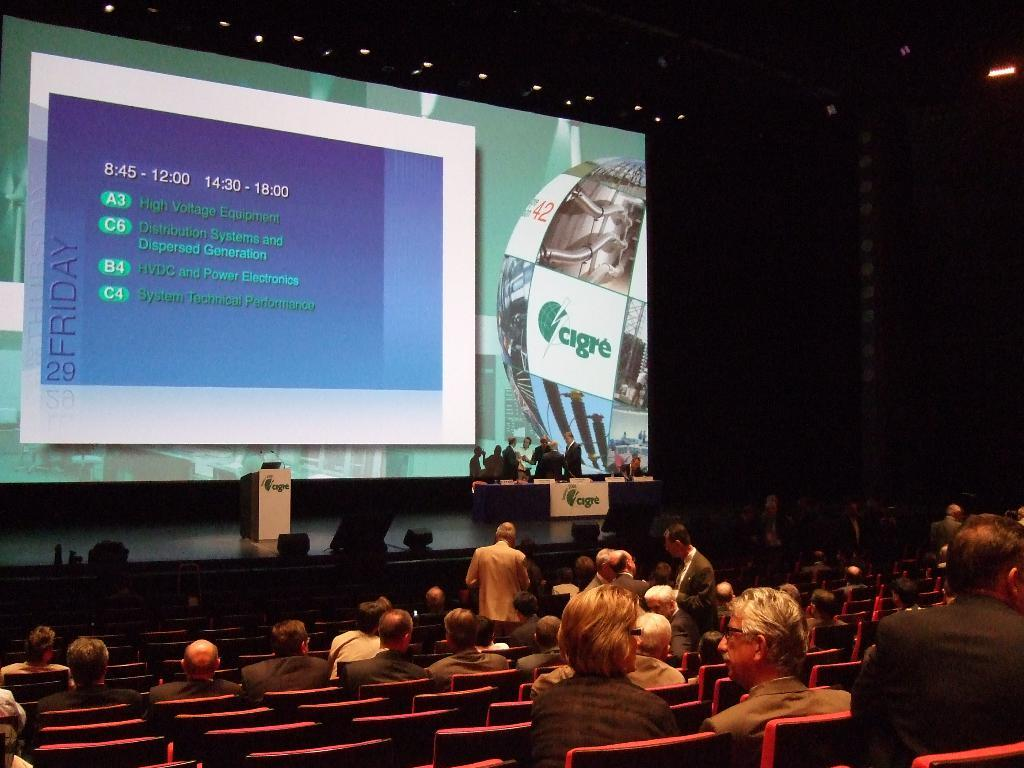<image>
Present a compact description of the photo's key features. Many people gather in the auditorium for the Cigre presentation 